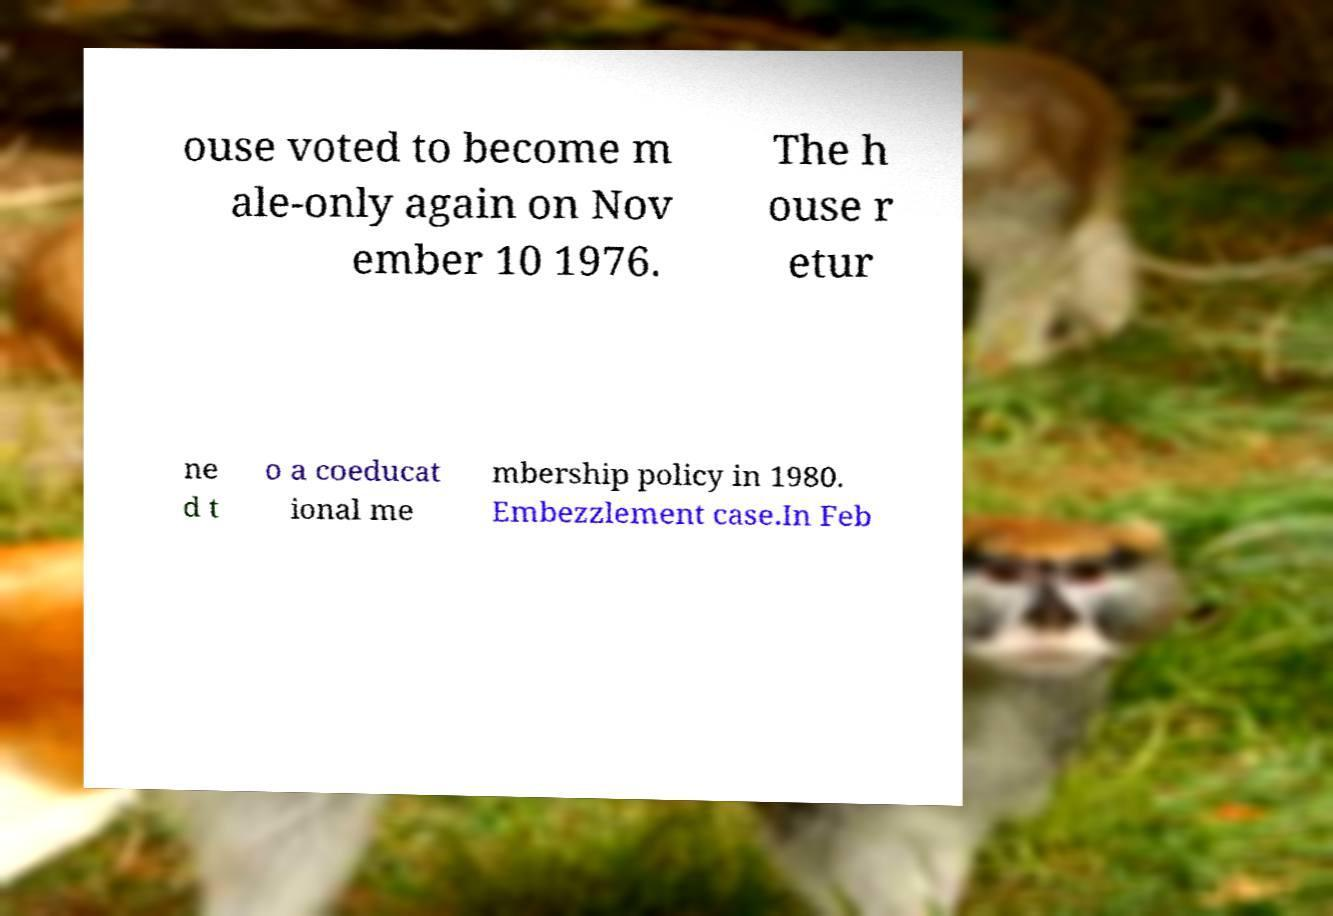Please identify and transcribe the text found in this image. ouse voted to become m ale-only again on Nov ember 10 1976. The h ouse r etur ne d t o a coeducat ional me mbership policy in 1980. Embezzlement case.In Feb 